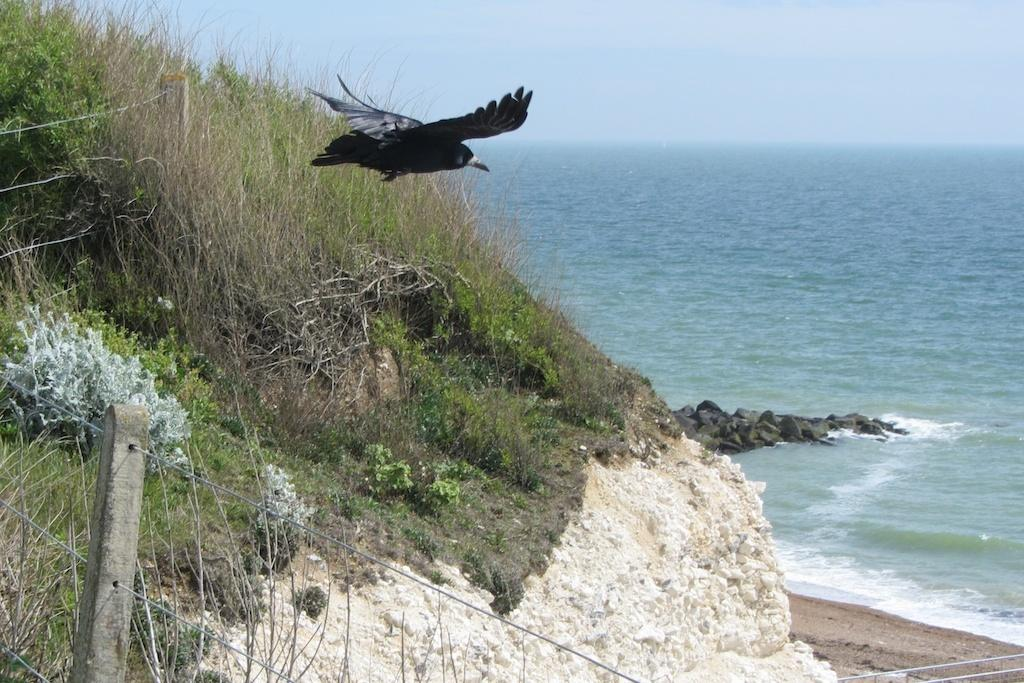What type of animal can be seen in the image? There is a bird in the image. What is the primary element in which the bird is situated? The bird is situated in water. What can be seen on the ground in the image? The ground is visible in the image. What type of terrain is present in the image? There is a hill in the image. What type of vegetation is present in the image? There is grass and plants in the image. What is the purpose of the fence in the image? The fence is present in the image, but its purpose cannot be determined from the facts provided. What is visible in the sky in the image? The sky is visible in the image. What type of flowers can be seen growing in the basket in the image? There is no basket or flowers present in the image. 